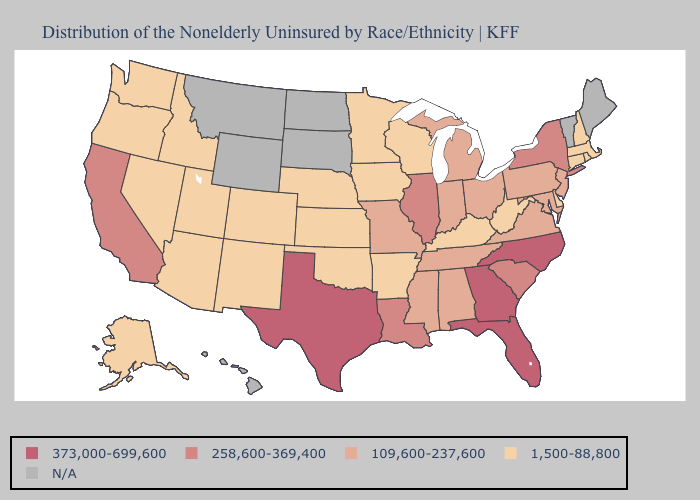What is the highest value in the Northeast ?
Be succinct. 258,600-369,400. Among the states that border Vermont , which have the lowest value?
Keep it brief. Massachusetts, New Hampshire. Does Rhode Island have the lowest value in the Northeast?
Short answer required. Yes. Does Nebraska have the lowest value in the MidWest?
Concise answer only. Yes. Which states have the lowest value in the USA?
Write a very short answer. Alaska, Arizona, Arkansas, Colorado, Connecticut, Delaware, Idaho, Iowa, Kansas, Kentucky, Massachusetts, Minnesota, Nebraska, Nevada, New Hampshire, New Mexico, Oklahoma, Oregon, Rhode Island, Utah, Washington, West Virginia, Wisconsin. Name the states that have a value in the range N/A?
Quick response, please. Hawaii, Maine, Montana, North Dakota, South Dakota, Vermont, Wyoming. What is the highest value in the USA?
Write a very short answer. 373,000-699,600. Name the states that have a value in the range 258,600-369,400?
Give a very brief answer. California, Illinois, Louisiana, New York, South Carolina. Which states hav the highest value in the Northeast?
Be succinct. New York. Does the first symbol in the legend represent the smallest category?
Keep it brief. No. 